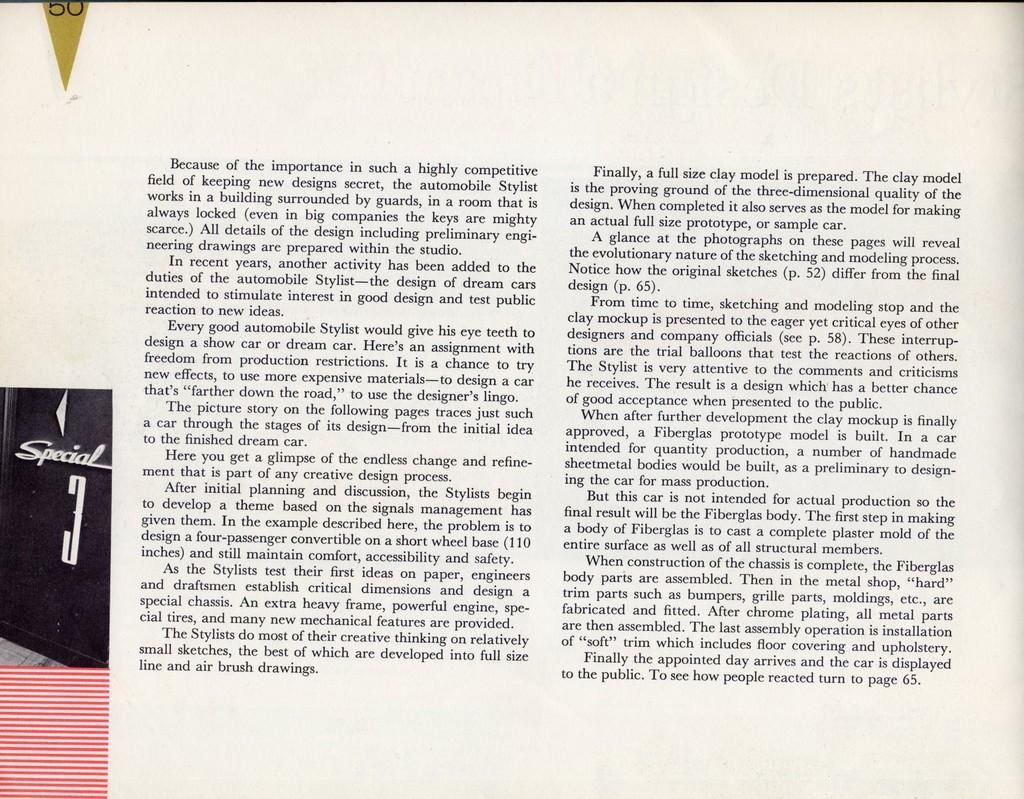What is the main subject of the image? The main subject of the image is a photo of a paper. What can be seen on the paper in the image? There is text visible on the paper. What type of food is being cooked in the image? There is no food or cooking activity present in the image. 